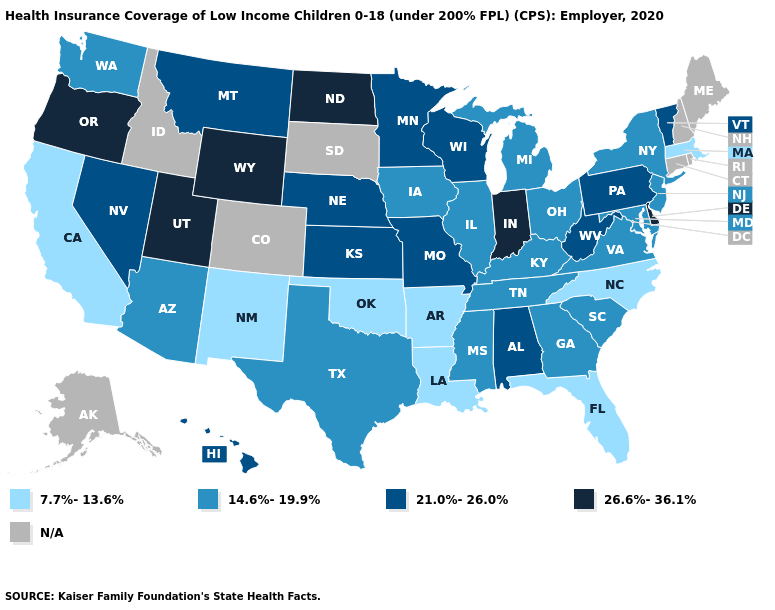What is the value of Massachusetts?
Give a very brief answer. 7.7%-13.6%. Does Nebraska have the highest value in the MidWest?
Concise answer only. No. What is the value of Idaho?
Give a very brief answer. N/A. Does the first symbol in the legend represent the smallest category?
Concise answer only. Yes. What is the value of Ohio?
Quick response, please. 14.6%-19.9%. Name the states that have a value in the range 14.6%-19.9%?
Be succinct. Arizona, Georgia, Illinois, Iowa, Kentucky, Maryland, Michigan, Mississippi, New Jersey, New York, Ohio, South Carolina, Tennessee, Texas, Virginia, Washington. Among the states that border South Carolina , which have the highest value?
Concise answer only. Georgia. Among the states that border Massachusetts , does New York have the lowest value?
Concise answer only. Yes. Which states hav the highest value in the South?
Keep it brief. Delaware. Name the states that have a value in the range 26.6%-36.1%?
Write a very short answer. Delaware, Indiana, North Dakota, Oregon, Utah, Wyoming. What is the value of Maine?
Answer briefly. N/A. Among the states that border Florida , which have the highest value?
Be succinct. Alabama. Name the states that have a value in the range 26.6%-36.1%?
Concise answer only. Delaware, Indiana, North Dakota, Oregon, Utah, Wyoming. 